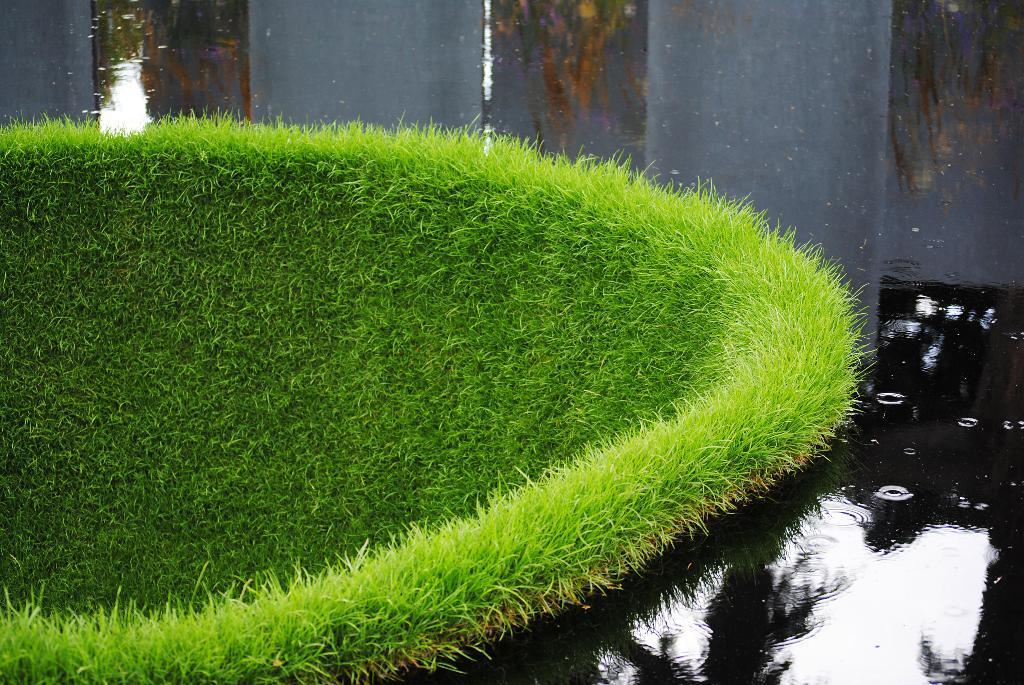What type of natural environment is depicted in the image? The image contains water and grass, which suggests a natural environment such as a park or a body of water. Can you describe the water in the image? The facts provided do not give specific details about the water, but we can confirm that there is water present in the image. What type of vegetation is visible in the image? Grass is visible in the image. Where is the judge sitting in the image? There is no judge present in the image. The image contains water and grass, which suggests a natural environment. 